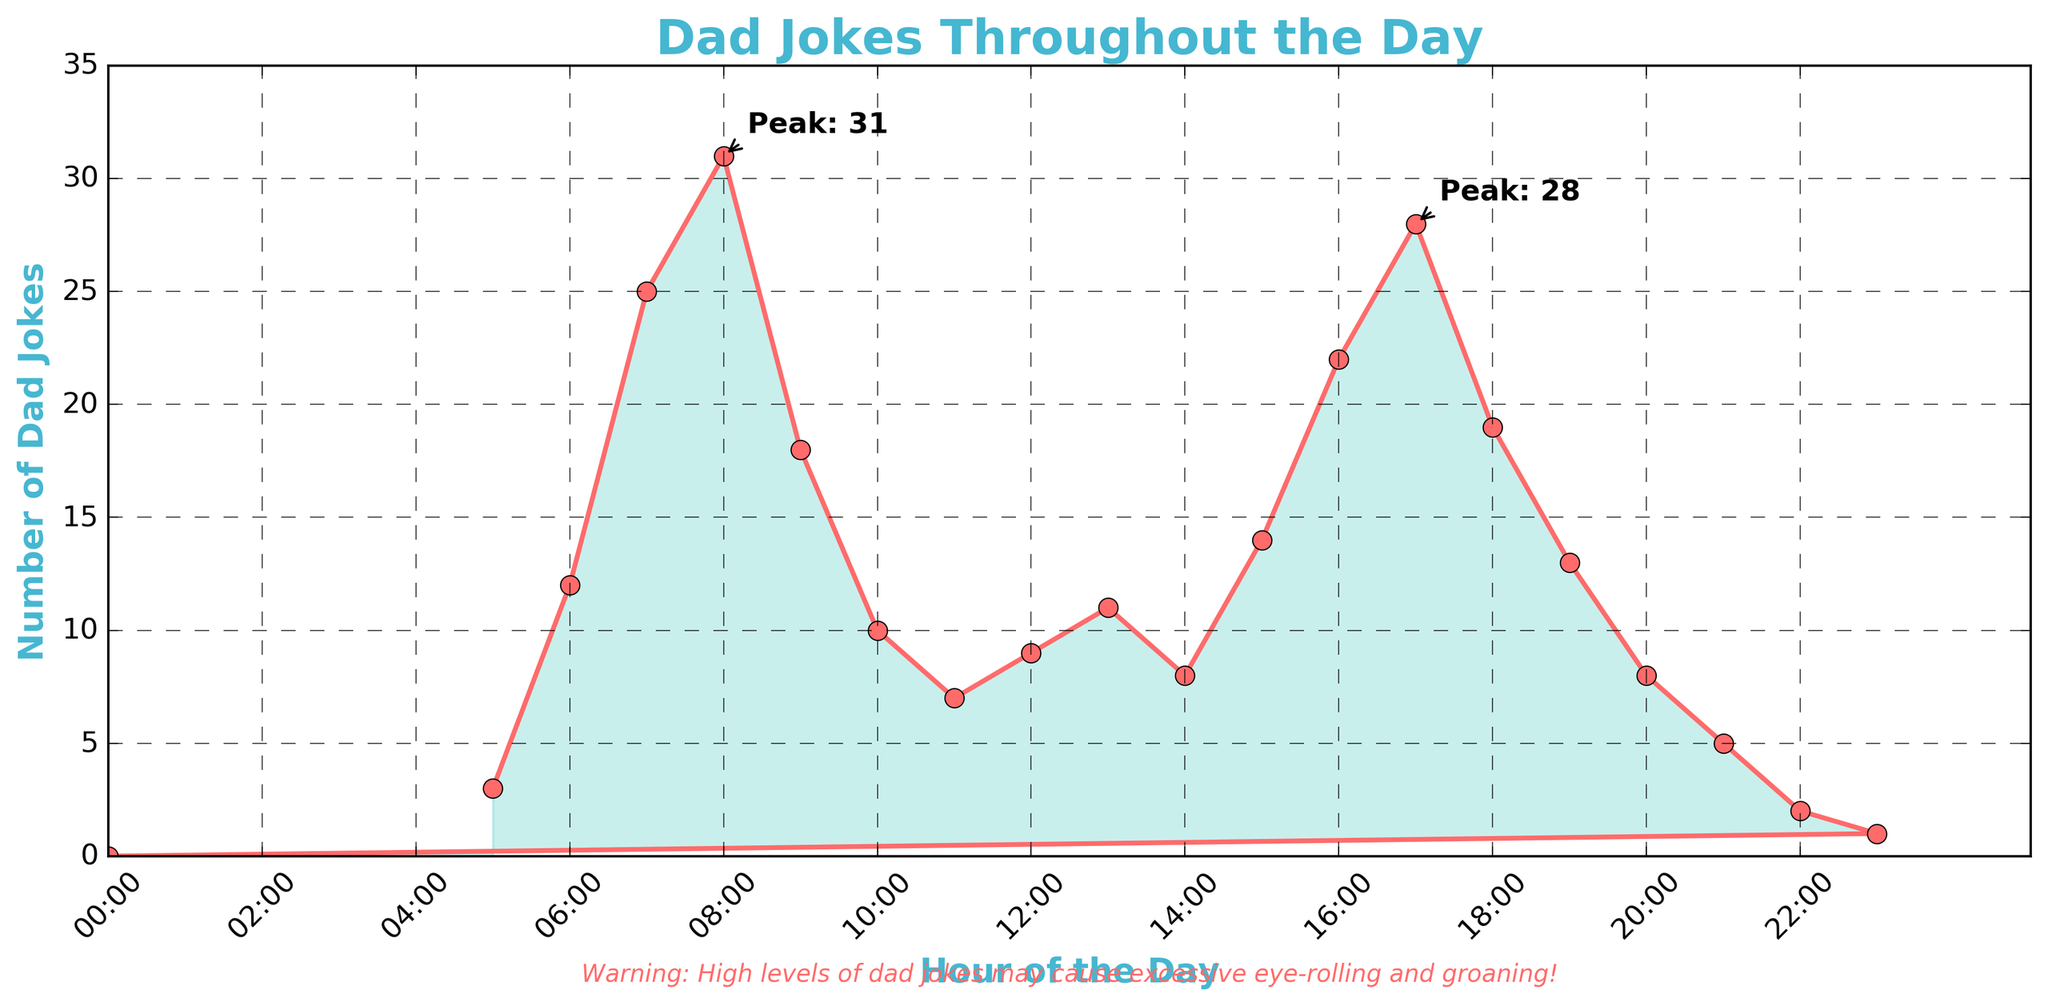What time of day sees the highest number of dad jokes? The highest peak on the plot occurs at 8:00 AM with 31 dad jokes. This can be identified by looking at the highest point on the curve.
Answer: 8:00 AM Which hour has more dad jokes, 5:00 PM or 8:00 PM? Comparing the values at 5:00 PM (28 dad jokes) and 8:00 PM (8 dad jokes), 5:00 PM has more dad jokes.
Answer: 5:00 PM What is the total number of dad jokes told between 6:00 AM and 10:00 AM? Summing up the values between 6:00 AM and 10:00 AM (12 + 25 + 31 + 18 + 10): 12 + 25 + 31 + 18 + 10 = 96 dad jokes.
Answer: 96 During which intervals do the number of dad jokes decrease continuously? Observing the plot for continuous declines, you see the values decrease between 8:00 AM to 11:00 AM and 5:00 PM to 10:00 PM.
Answer: 8:00 AM to 11:00 AM and 5:00 PM to 10:00 PM How many dad jokes are told when the number is at its lowest, excluding zero? The lowest non-zero value occurs at 11:00 PM with 1 dad joke.
Answer: 1 Do more or fewer dad jokes get told during the morning (5:00 AM - 12:00 PM) than during the evening (6:00 PM - 12:00 AM)? Adding up morning jokes (3 + 12 + 25 + 31 + 18 + 10 + 7 + 9): 115 and evening jokes (19 + 13 + 8 + 5 + 2 + 1 + 0): 48. More dad jokes are told in the morning.
Answer: Morning What is the average number of dad jokes told per hour between 4:00 PM and 8:00 PM? Calculating the average for the values (22 + 28 + 19 + 13 + 8): (22 + 28 + 19 + 13 + 8) / 5 = 18.
Answer: 18 Is the number of dad jokes higher at 3:00 PM or at 9:00 PM? Comparing the values at 3:00 PM (14 dad jokes) and 9:00 PM (5 dad jokes), 3:00 PM has more dad jokes.
Answer: 3:00 PM What is the difference in the number of dad jokes between the peak hour and the hour right after the peak? The peak hour is 8:00 AM with 31 dad jokes and the hour right after is 9:00 AM with 18 dad jokes. The difference is 31 - 18 = 13.
Answer: 13 Between 6:00 AM to 11:00 AM, which hour has the least number of dad jokes? Looking at the plot, 11:00 AM has the least number of dad jokes with 7.
Answer: 11:00 AM 